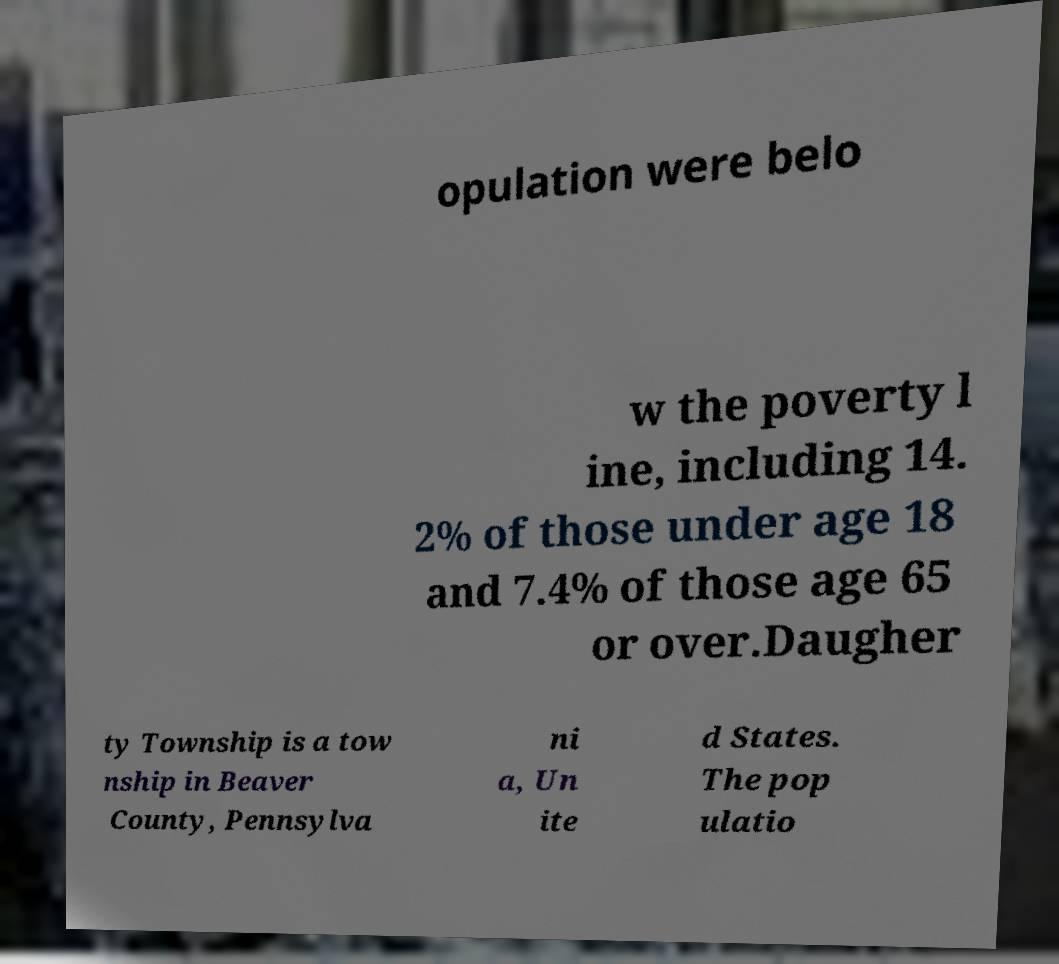Please identify and transcribe the text found in this image. opulation were belo w the poverty l ine, including 14. 2% of those under age 18 and 7.4% of those age 65 or over.Daugher ty Township is a tow nship in Beaver County, Pennsylva ni a, Un ite d States. The pop ulatio 